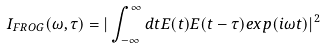<formula> <loc_0><loc_0><loc_500><loc_500>I _ { F R O G } ( \omega , \tau ) = | \int _ { - \infty } ^ { \infty } d t E ( t ) E ( t - \tau ) e x p ( i \omega t ) | ^ { 2 }</formula> 